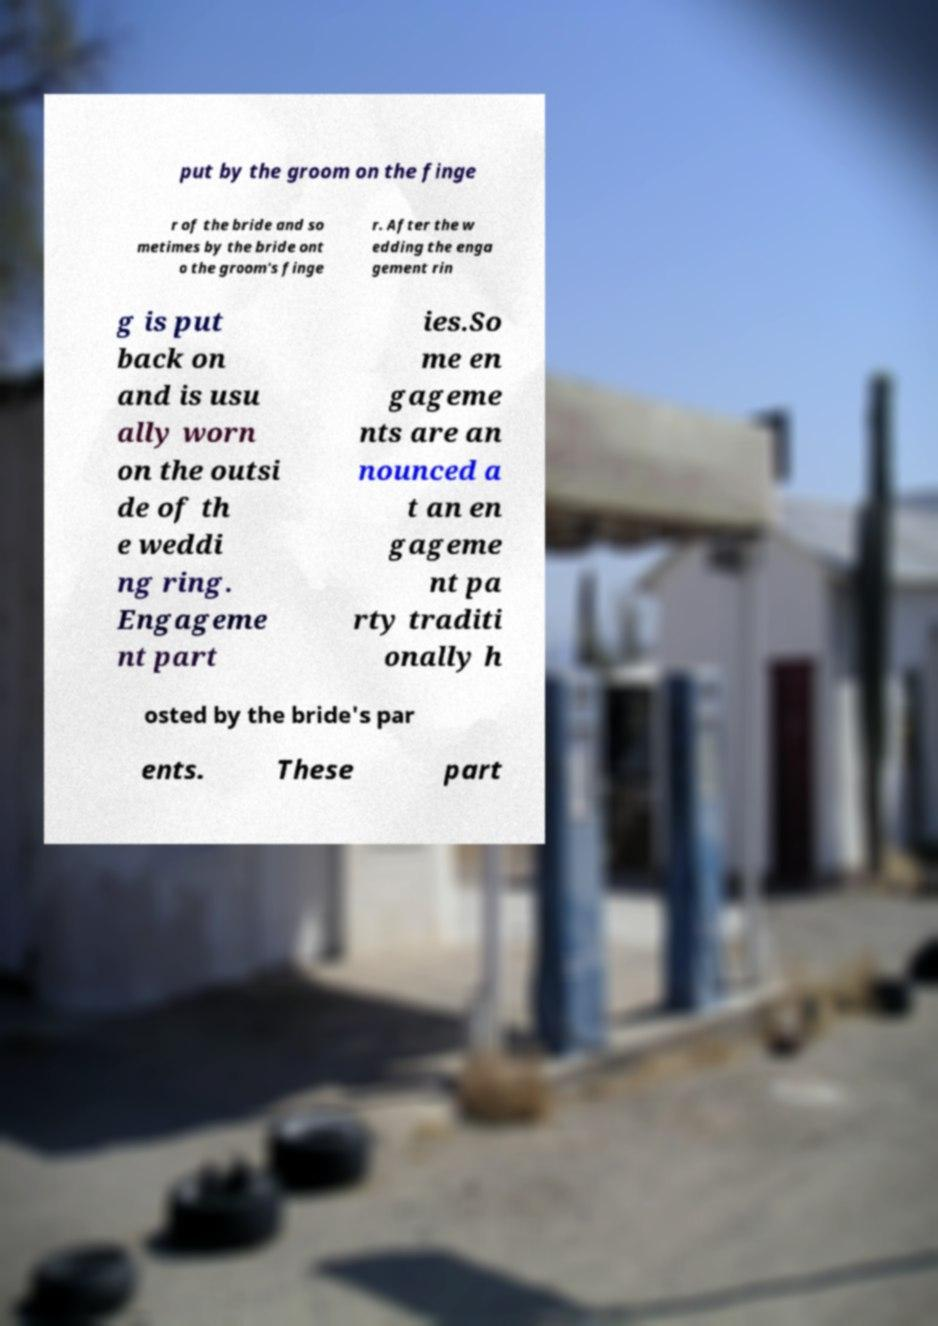For documentation purposes, I need the text within this image transcribed. Could you provide that? put by the groom on the finge r of the bride and so metimes by the bride ont o the groom's finge r. After the w edding the enga gement rin g is put back on and is usu ally worn on the outsi de of th e weddi ng ring. Engageme nt part ies.So me en gageme nts are an nounced a t an en gageme nt pa rty traditi onally h osted by the bride's par ents. These part 